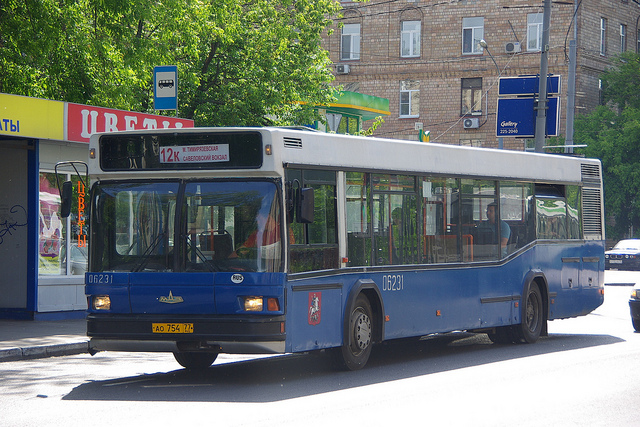Please extract the text content from this image. 06231 12 K TBL 